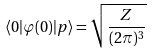Convert formula to latex. <formula><loc_0><loc_0><loc_500><loc_500>\langle 0 | \varphi ( 0 ) | p \rangle = { \sqrt { \frac { Z } { ( 2 \pi ) ^ { 3 } } } }</formula> 